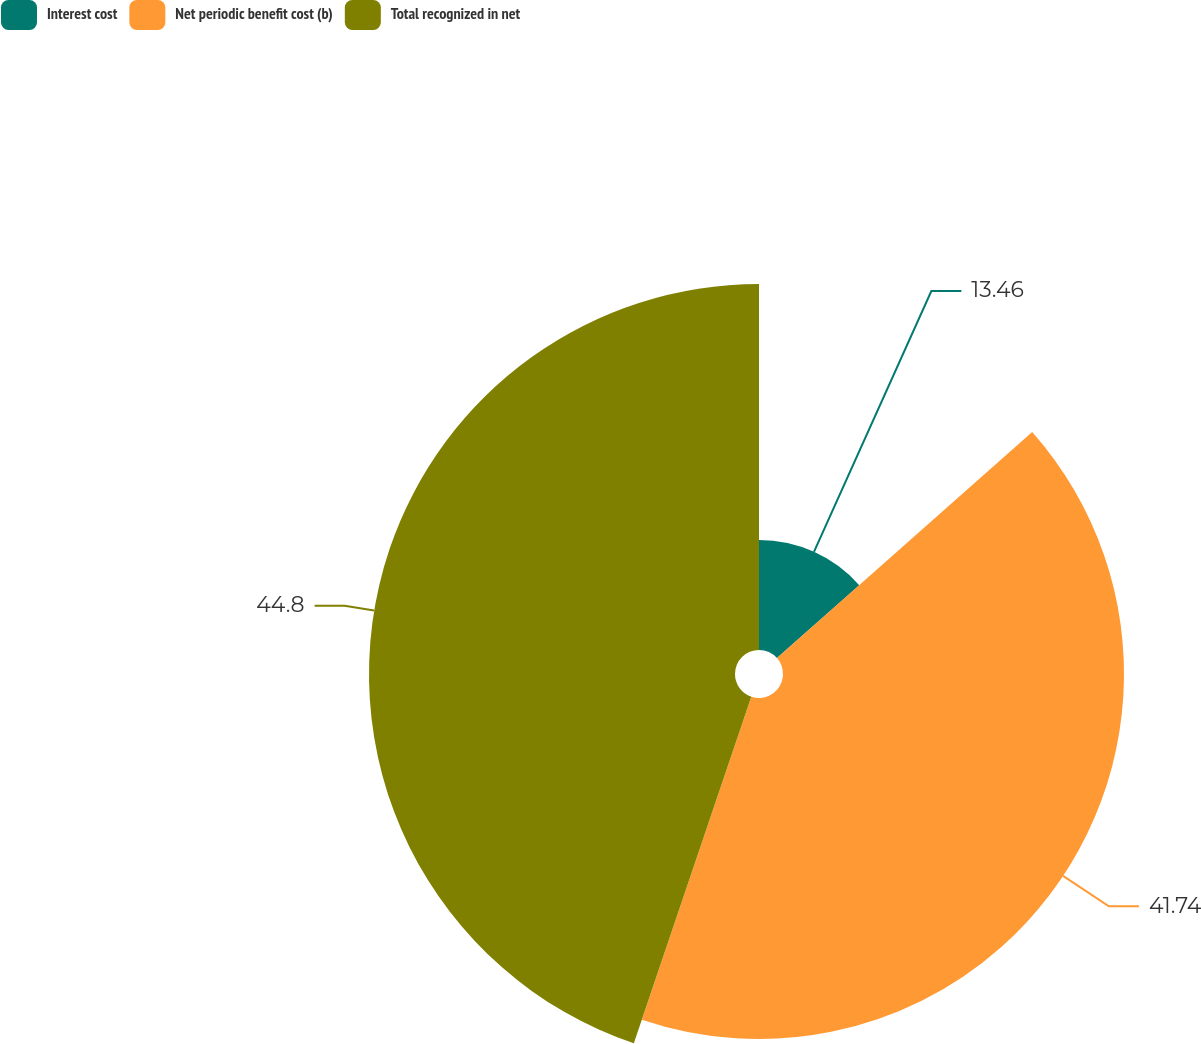Convert chart to OTSL. <chart><loc_0><loc_0><loc_500><loc_500><pie_chart><fcel>Interest cost<fcel>Net periodic benefit cost (b)<fcel>Total recognized in net<nl><fcel>13.46%<fcel>41.74%<fcel>44.8%<nl></chart> 